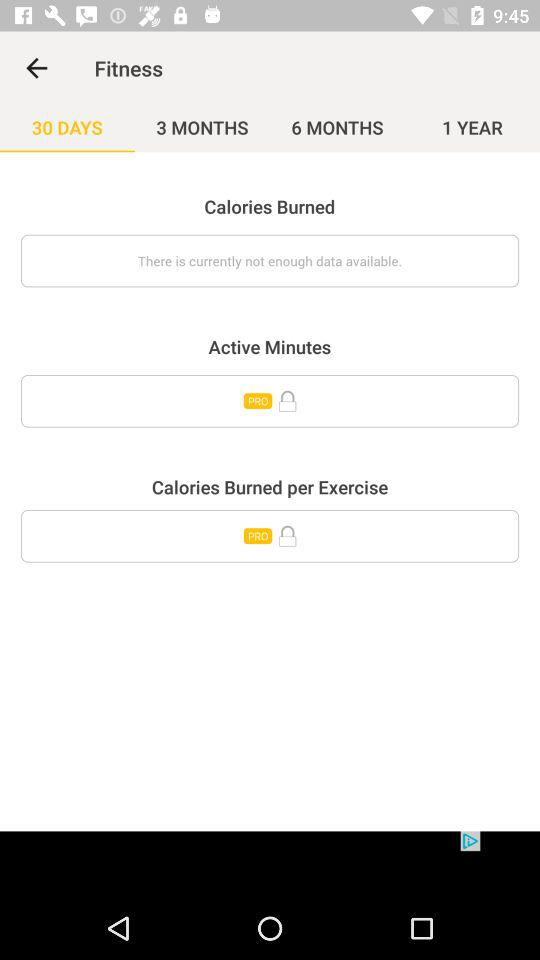Which tab is selected? The selected tab is "30 DAYS". 